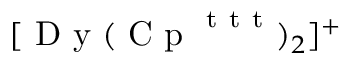<formula> <loc_0><loc_0><loc_500><loc_500>[ D y ( C p ^ { t t t } ) _ { 2 } ] ^ { + }</formula> 